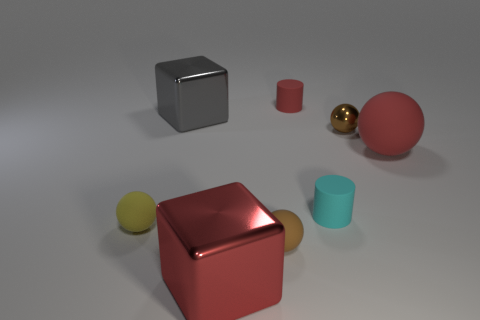How many other things are there of the same color as the big rubber ball?
Offer a very short reply. 2. Is the material of the thing that is on the left side of the big gray metallic cube the same as the cylinder that is in front of the brown shiny object?
Offer a terse response. Yes. How many things are metallic objects to the right of the gray block or small things on the right side of the brown matte ball?
Keep it short and to the point. 4. Are there any other things that have the same shape as the small yellow thing?
Keep it short and to the point. Yes. What number of tiny yellow matte things are there?
Provide a short and direct response. 1. Is there a brown cylinder that has the same size as the brown metallic sphere?
Provide a succinct answer. No. Are the yellow ball and the small cylinder that is in front of the big red matte object made of the same material?
Provide a short and direct response. Yes. What material is the tiny cylinder behind the large gray cube?
Make the answer very short. Rubber. What is the size of the metal ball?
Make the answer very short. Small. There is a cylinder in front of the small metal thing; is it the same size as the metallic block that is behind the brown shiny object?
Make the answer very short. No. 